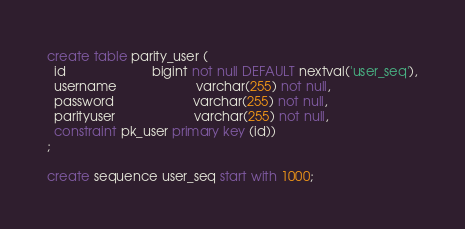<code> <loc_0><loc_0><loc_500><loc_500><_SQL_>create table parity_user (
  id                        bigint not null DEFAULT nextval('user_seq'),
  username                      varchar(255) not null,
  password                      varchar(255) not null,
  parityuser                      varchar(255) not null,
  constraint pk_user primary key (id))
;

create sequence user_seq start with 1000;</code> 